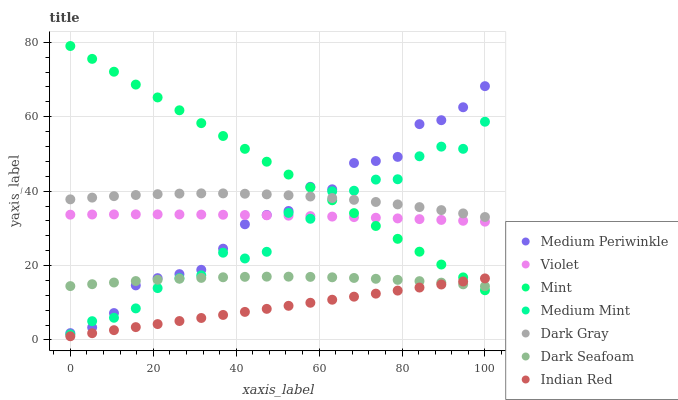Does Indian Red have the minimum area under the curve?
Answer yes or no. Yes. Does Mint have the maximum area under the curve?
Answer yes or no. Yes. Does Medium Periwinkle have the minimum area under the curve?
Answer yes or no. No. Does Medium Periwinkle have the maximum area under the curve?
Answer yes or no. No. Is Indian Red the smoothest?
Answer yes or no. Yes. Is Medium Mint the roughest?
Answer yes or no. Yes. Is Medium Periwinkle the smoothest?
Answer yes or no. No. Is Medium Periwinkle the roughest?
Answer yes or no. No. Does Indian Red have the lowest value?
Answer yes or no. Yes. Does Medium Periwinkle have the lowest value?
Answer yes or no. No. Does Mint have the highest value?
Answer yes or no. Yes. Does Medium Periwinkle have the highest value?
Answer yes or no. No. Is Dark Seafoam less than Violet?
Answer yes or no. Yes. Is Dark Gray greater than Indian Red?
Answer yes or no. Yes. Does Dark Seafoam intersect Medium Periwinkle?
Answer yes or no. Yes. Is Dark Seafoam less than Medium Periwinkle?
Answer yes or no. No. Is Dark Seafoam greater than Medium Periwinkle?
Answer yes or no. No. Does Dark Seafoam intersect Violet?
Answer yes or no. No. 